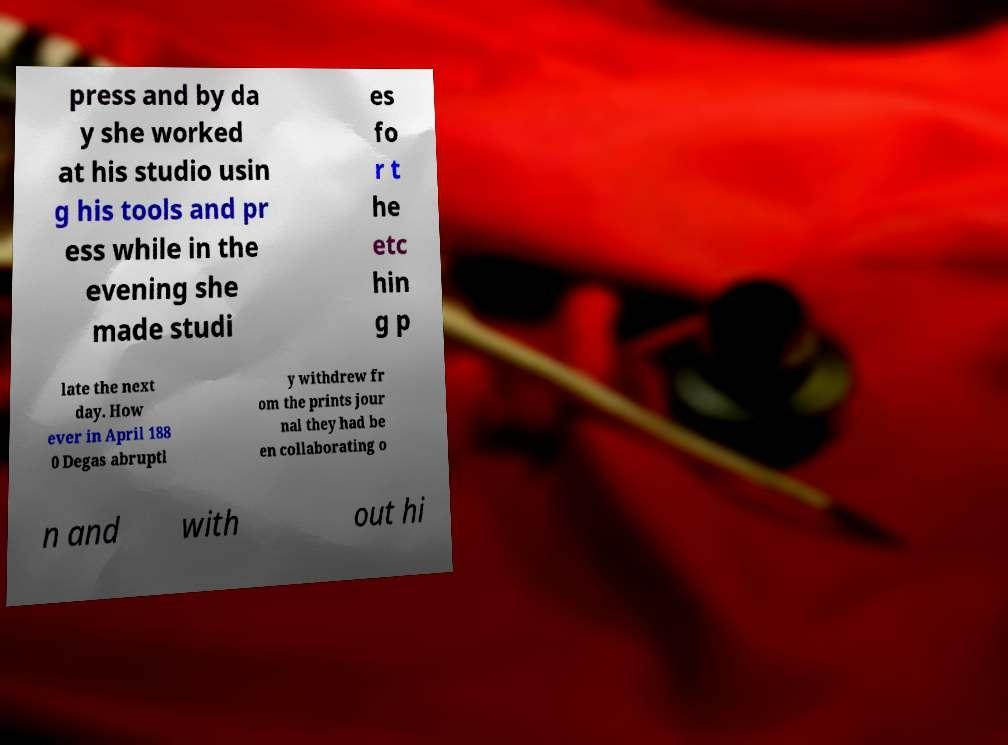Could you extract and type out the text from this image? press and by da y she worked at his studio usin g his tools and pr ess while in the evening she made studi es fo r t he etc hin g p late the next day. How ever in April 188 0 Degas abruptl y withdrew fr om the prints jour nal they had be en collaborating o n and with out hi 